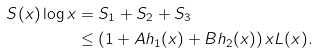<formula> <loc_0><loc_0><loc_500><loc_500>S ( x ) \log x & = S _ { 1 } + S _ { 2 } + S _ { 3 } \\ & \leq \left ( 1 + A h _ { 1 } ( x ) + B h _ { 2 } ( x ) \right ) x L ( x ) . \\</formula> 